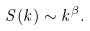Convert formula to latex. <formula><loc_0><loc_0><loc_500><loc_500>S ( k ) \sim k ^ { \beta } .</formula> 